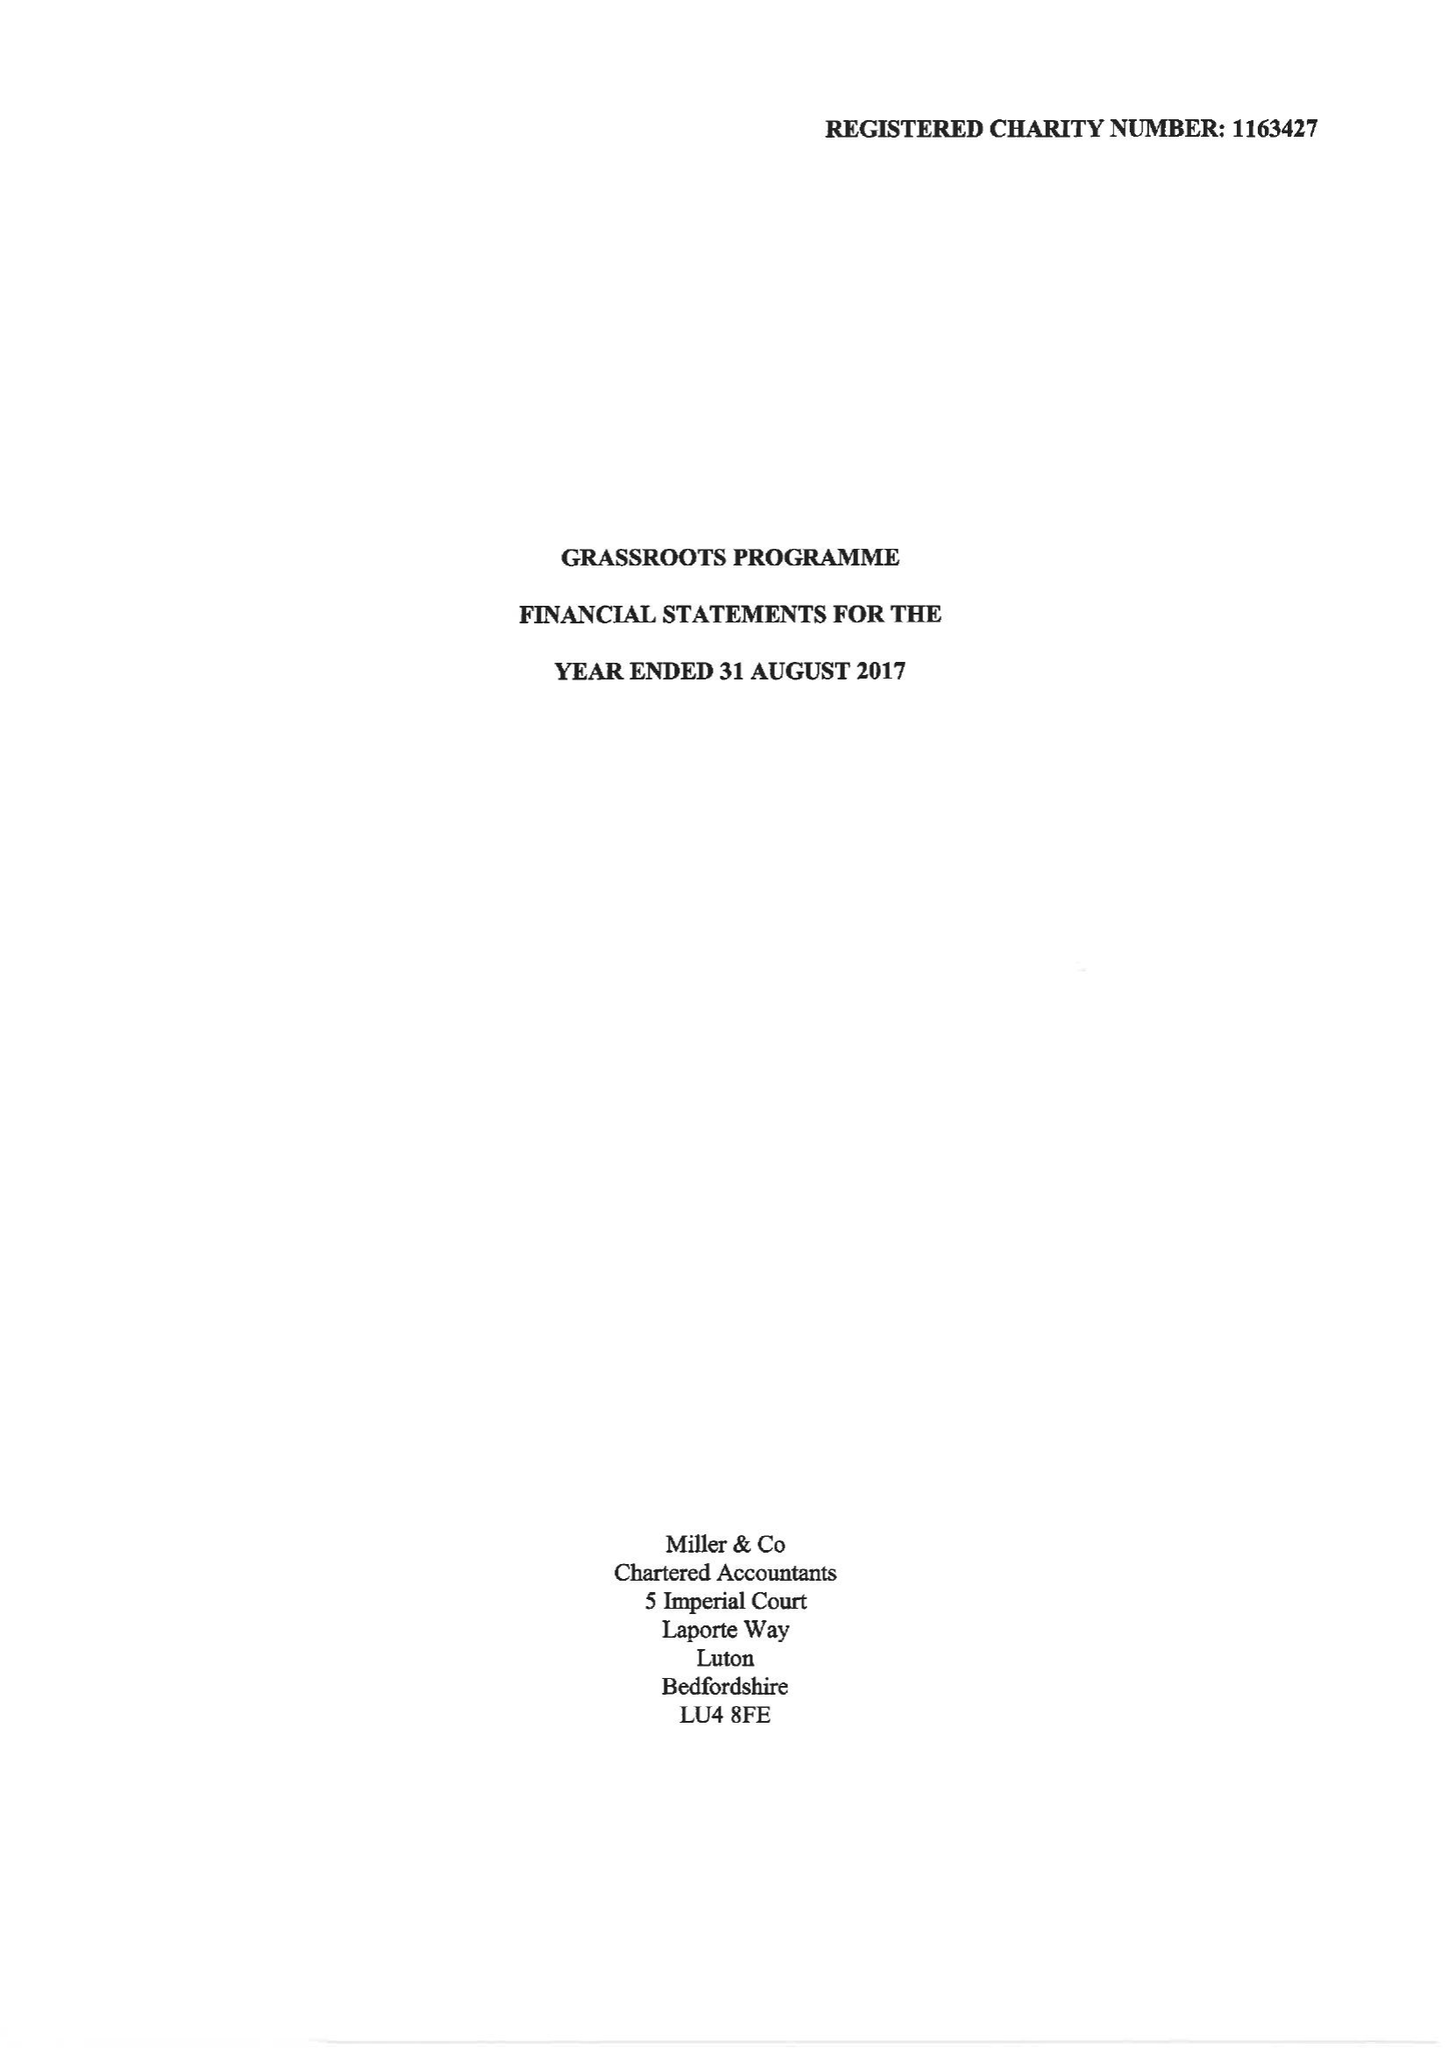What is the value for the address__street_line?
Answer the question using a single word or phrase. 47 HIGH TOWN ROAD 